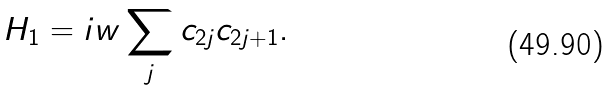Convert formula to latex. <formula><loc_0><loc_0><loc_500><loc_500>H _ { 1 } = i w \sum _ { j } c _ { 2 j } c _ { 2 j + 1 } .</formula> 